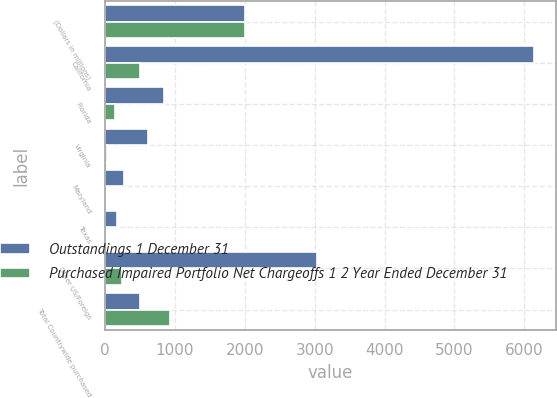Convert chart to OTSL. <chart><loc_0><loc_0><loc_500><loc_500><stacked_bar_chart><ecel><fcel>(Dollars in millions)<fcel>California<fcel>Florida<fcel>Virginia<fcel>Maryland<fcel>Texas<fcel>Other US/Foreign<fcel>Total Countrywide purchased<nl><fcel>Outstandings 1 December 31<fcel>2009<fcel>6142<fcel>843<fcel>617<fcel>278<fcel>166<fcel>3031<fcel>496<nl><fcel>Purchased Impaired Portfolio Net Chargeoffs 1 2 Year Ended December 31<fcel>2009<fcel>496<fcel>143<fcel>30<fcel>13<fcel>5<fcel>237<fcel>924<nl></chart> 